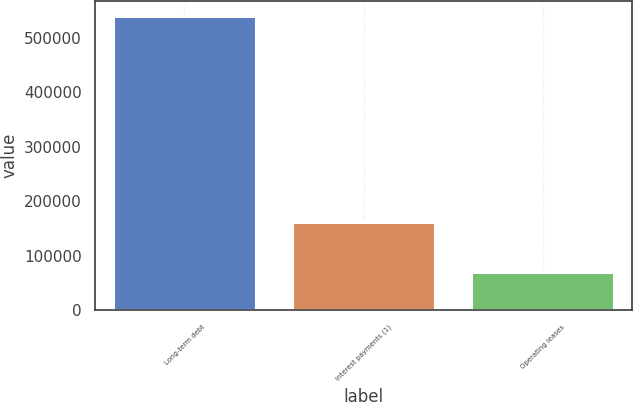<chart> <loc_0><loc_0><loc_500><loc_500><bar_chart><fcel>Long-term debt<fcel>Interest payments (1)<fcel>Operating leases<nl><fcel>540000<fcel>162211<fcel>69917<nl></chart> 